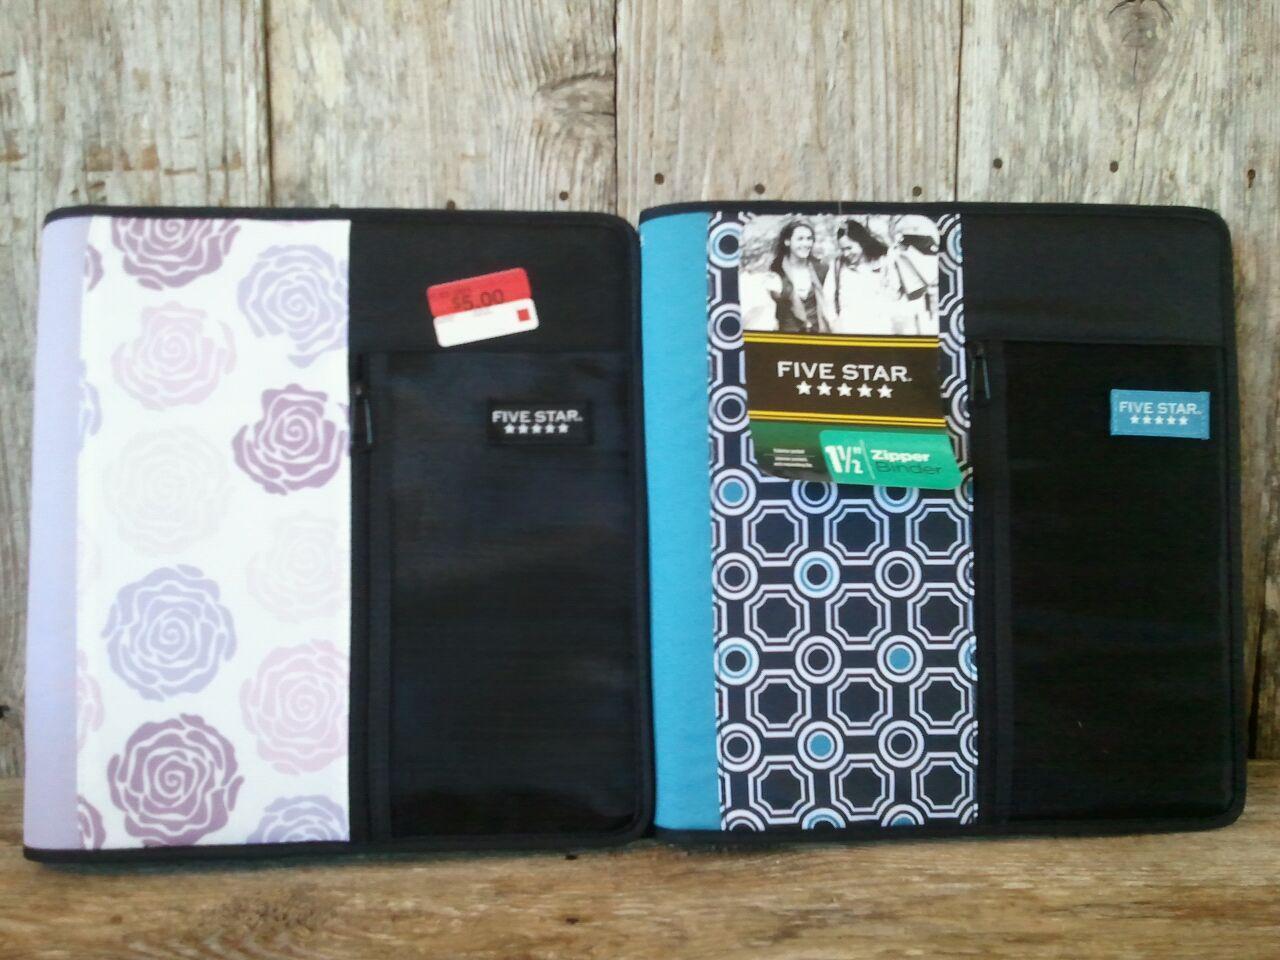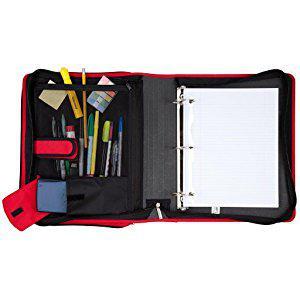The first image is the image on the left, the second image is the image on the right. Evaluate the accuracy of this statement regarding the images: "The open trapper keeper is filled with paper and other items". Is it true? Answer yes or no. Yes. The first image is the image on the left, the second image is the image on the right. Examine the images to the left and right. Is the description "The open notebooks contain multiple items; they are not empty." accurate? Answer yes or no. Yes. 